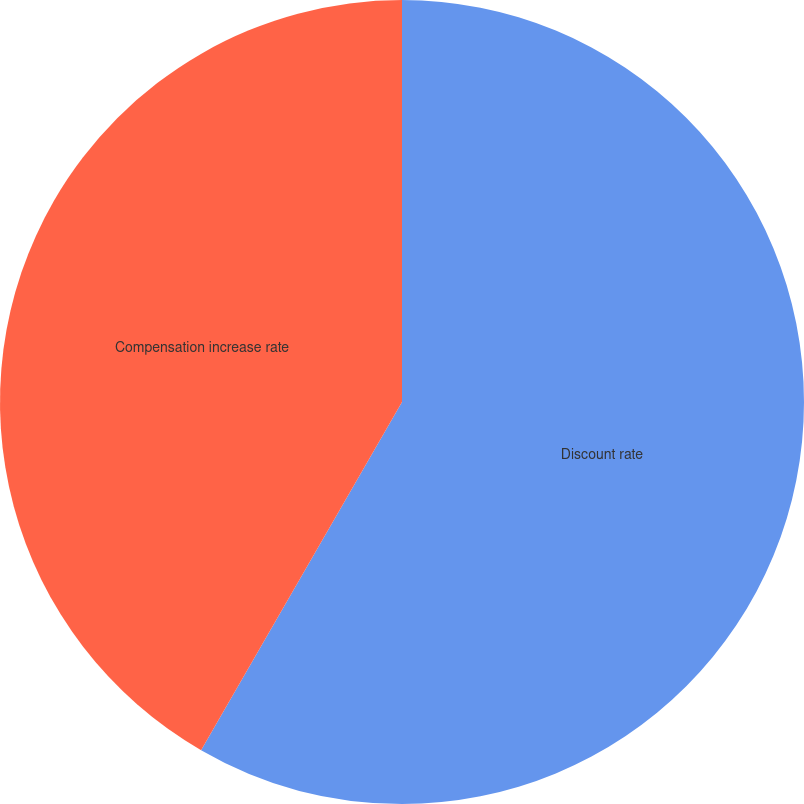Convert chart. <chart><loc_0><loc_0><loc_500><loc_500><pie_chart><fcel>Discount rate<fcel>Compensation increase rate<nl><fcel>58.33%<fcel>41.67%<nl></chart> 